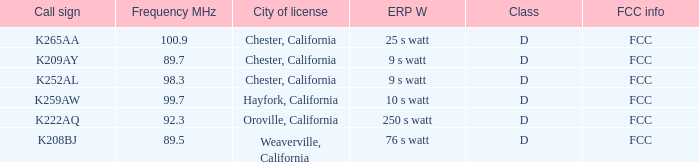Name the sum of frequency will call sign of k259aw 99.7. Help me parse the entirety of this table. {'header': ['Call sign', 'Frequency MHz', 'City of license', 'ERP W', 'Class', 'FCC info'], 'rows': [['K265AA', '100.9', 'Chester, California', '25 s watt', 'D', 'FCC'], ['K209AY', '89.7', 'Chester, California', '9 s watt', 'D', 'FCC'], ['K252AL', '98.3', 'Chester, California', '9 s watt', 'D', 'FCC'], ['K259AW', '99.7', 'Hayfork, California', '10 s watt', 'D', 'FCC'], ['K222AQ', '92.3', 'Oroville, California', '250 s watt', 'D', 'FCC'], ['K208BJ', '89.5', 'Weaverville, California', '76 s watt', 'D', 'FCC']]} 